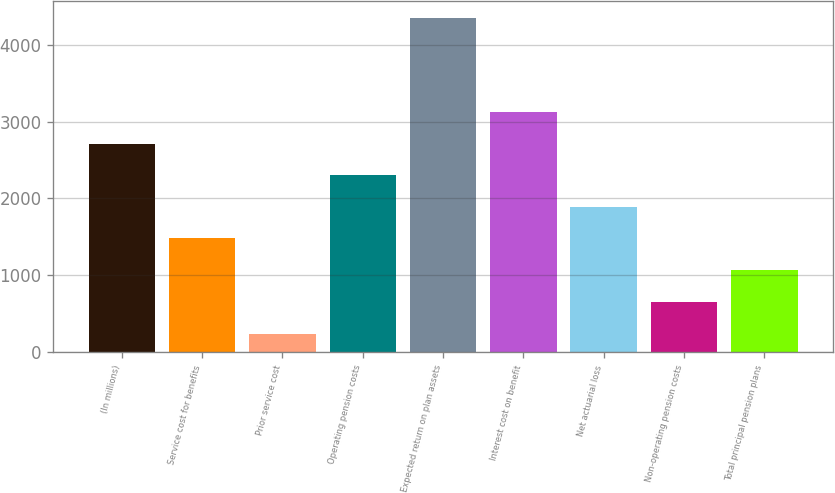Convert chart to OTSL. <chart><loc_0><loc_0><loc_500><loc_500><bar_chart><fcel>(In millions)<fcel>Service cost for benefits<fcel>Prior service cost<fcel>Operating pension costs<fcel>Expected return on plan assets<fcel>Interest cost on benefit<fcel>Net actuarial loss<fcel>Non-operating pension costs<fcel>Total principal pension plans<nl><fcel>2714.4<fcel>1482.6<fcel>238<fcel>2303.8<fcel>4344<fcel>3125<fcel>1893.2<fcel>648.6<fcel>1072<nl></chart> 